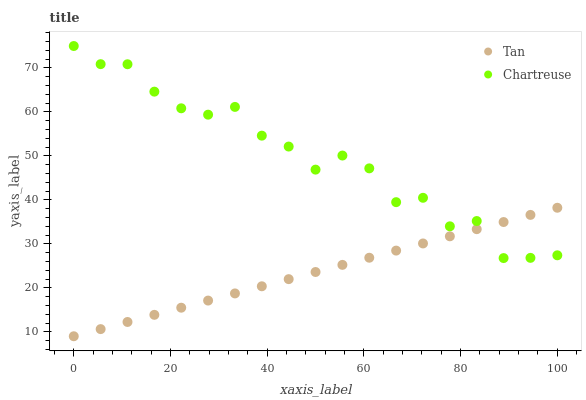Does Tan have the minimum area under the curve?
Answer yes or no. Yes. Does Chartreuse have the maximum area under the curve?
Answer yes or no. Yes. Does Chartreuse have the minimum area under the curve?
Answer yes or no. No. Is Tan the smoothest?
Answer yes or no. Yes. Is Chartreuse the roughest?
Answer yes or no. Yes. Is Chartreuse the smoothest?
Answer yes or no. No. Does Tan have the lowest value?
Answer yes or no. Yes. Does Chartreuse have the lowest value?
Answer yes or no. No. Does Chartreuse have the highest value?
Answer yes or no. Yes. Does Tan intersect Chartreuse?
Answer yes or no. Yes. Is Tan less than Chartreuse?
Answer yes or no. No. Is Tan greater than Chartreuse?
Answer yes or no. No. 